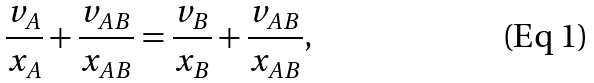<formula> <loc_0><loc_0><loc_500><loc_500>\frac { v _ { A } } { x _ { A } } + \frac { v _ { A B } } { x _ { A B } } = \frac { v _ { B } } { x _ { B } } + \frac { v _ { A B } } { x _ { A B } } ,</formula> 